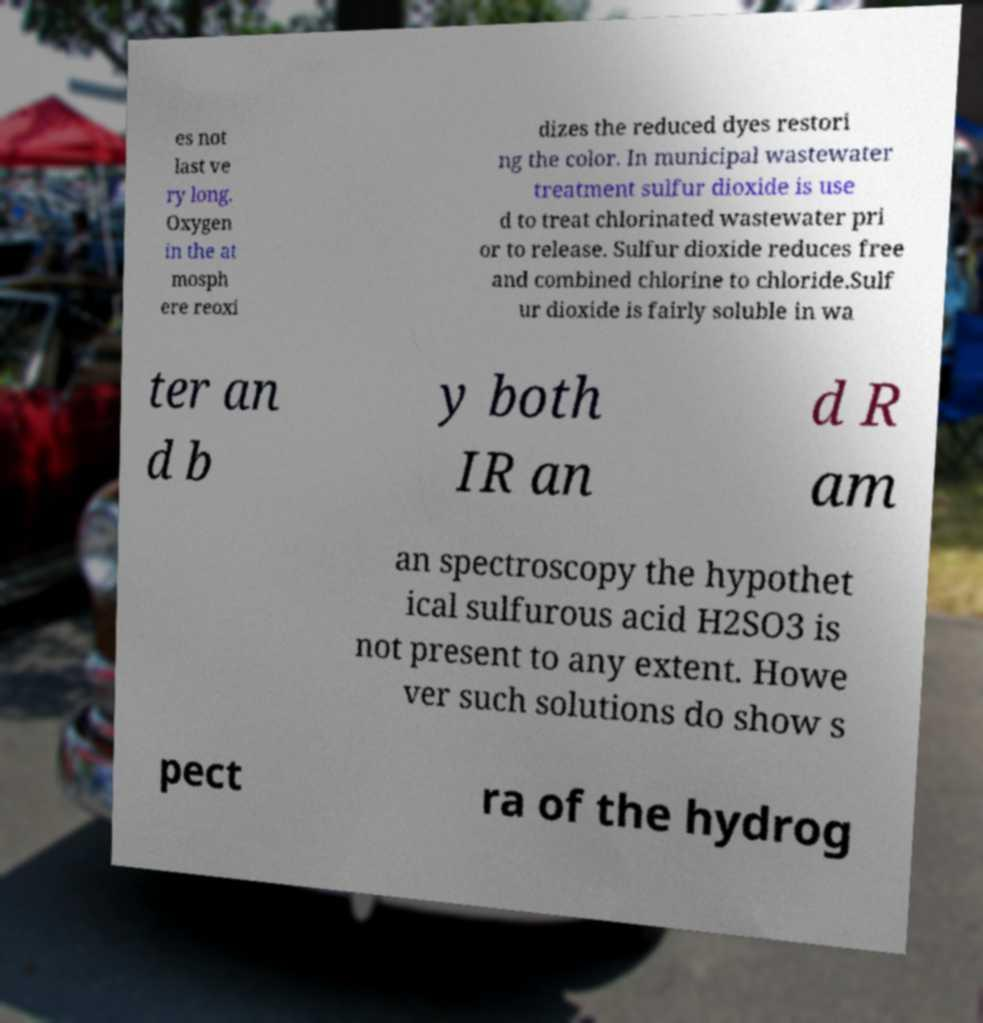There's text embedded in this image that I need extracted. Can you transcribe it verbatim? es not last ve ry long. Oxygen in the at mosph ere reoxi dizes the reduced dyes restori ng the color. In municipal wastewater treatment sulfur dioxide is use d to treat chlorinated wastewater pri or to release. Sulfur dioxide reduces free and combined chlorine to chloride.Sulf ur dioxide is fairly soluble in wa ter an d b y both IR an d R am an spectroscopy the hypothet ical sulfurous acid H2SO3 is not present to any extent. Howe ver such solutions do show s pect ra of the hydrog 